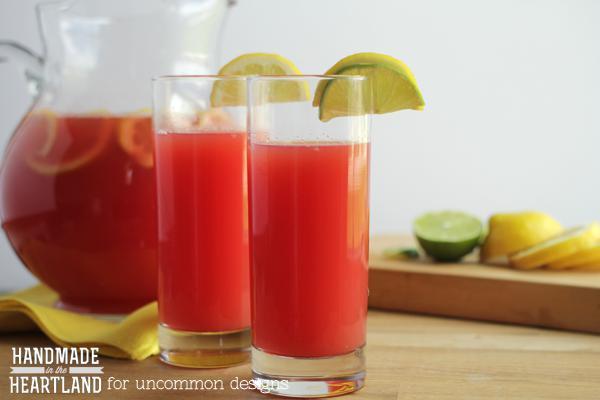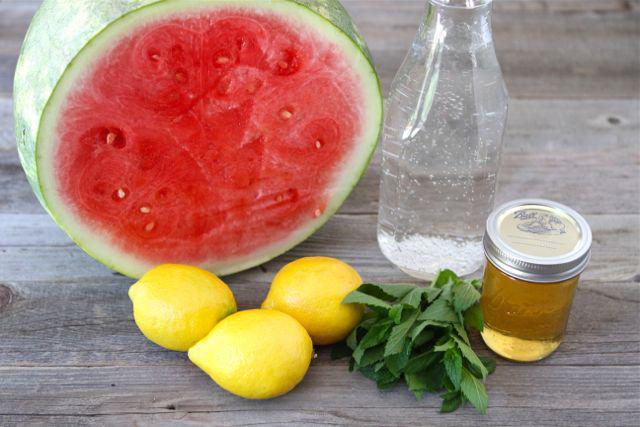The first image is the image on the left, the second image is the image on the right. For the images displayed, is the sentence "There is exactly one full lemon in the image on the right." factually correct? Answer yes or no. No. 